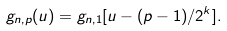<formula> <loc_0><loc_0><loc_500><loc_500>g _ { n , p } ( u ) = g _ { n , 1 } [ u - ( p - 1 ) / 2 ^ { k } ] .</formula> 